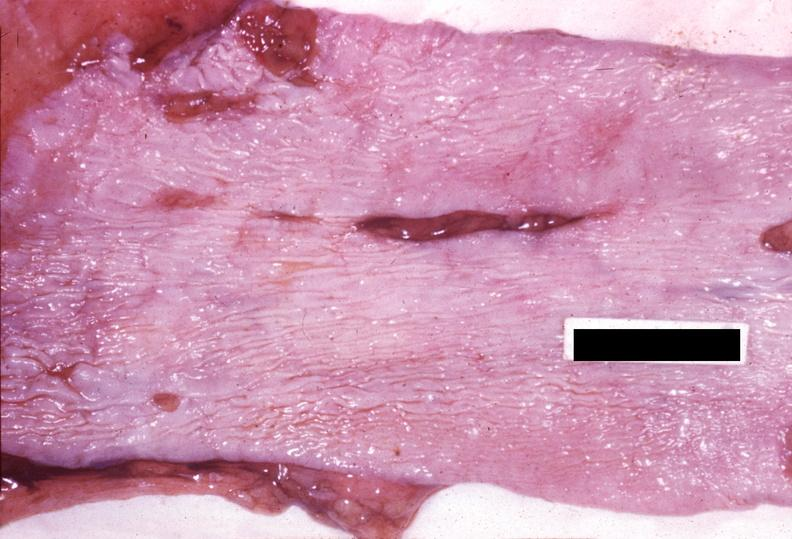s gastrointestinal present?
Answer the question using a single word or phrase. Yes 